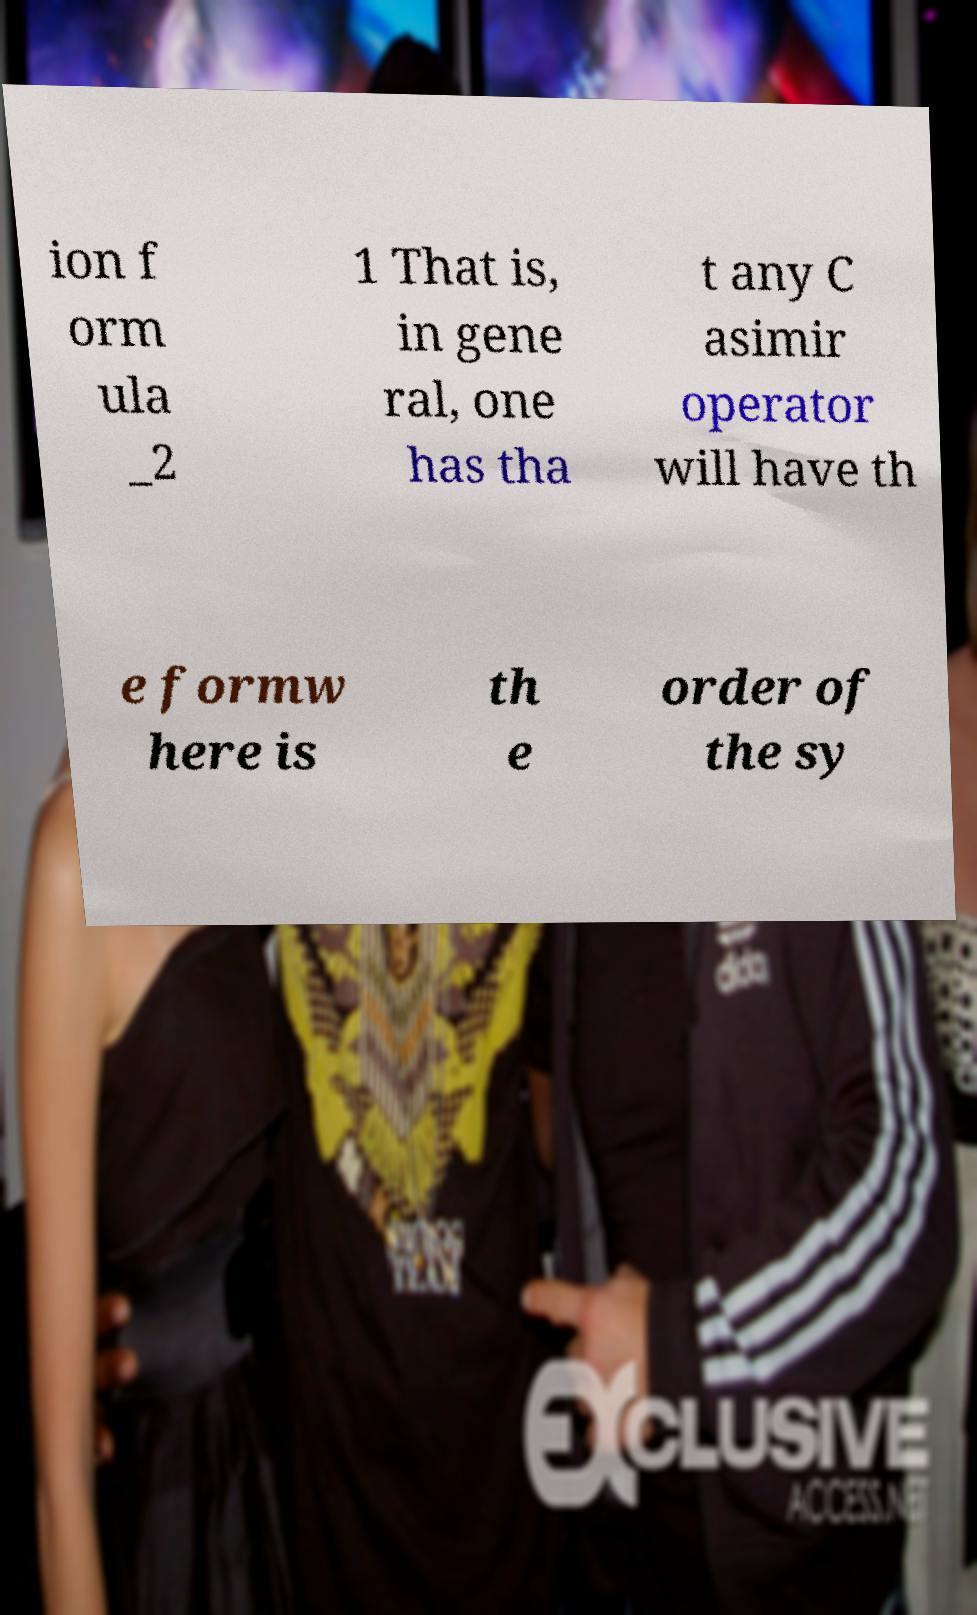I need the written content from this picture converted into text. Can you do that? ion f orm ula _2 1 That is, in gene ral, one has tha t any C asimir operator will have th e formw here is th e order of the sy 